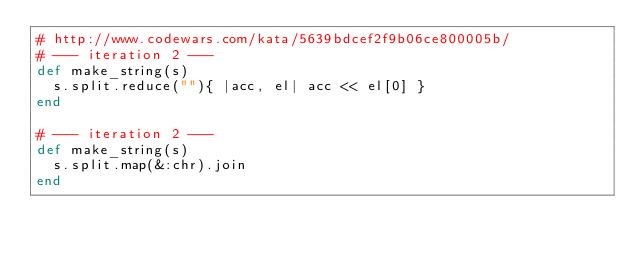Convert code to text. <code><loc_0><loc_0><loc_500><loc_500><_Ruby_># http://www.codewars.com/kata/5639bdcef2f9b06ce800005b/
# --- iteration 2 ---
def make_string(s)
  s.split.reduce(""){ |acc, el| acc << el[0] }
end

# --- iteration 2 ---
def make_string(s)
  s.split.map(&:chr).join
end
</code> 